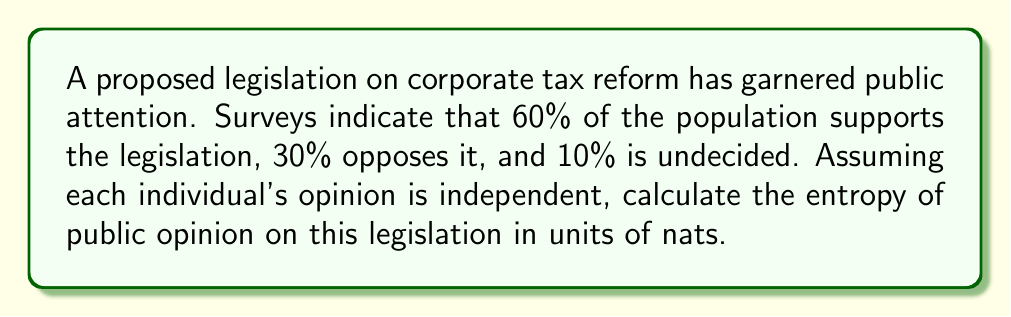Provide a solution to this math problem. To calculate the entropy of public opinion, we'll use the Shannon entropy formula:

$$S = -\sum_{i} p_i \ln(p_i)$$

Where:
$S$ is the entropy
$p_i$ is the probability of each outcome

Step 1: Identify the probabilities
$p_1 = 0.60$ (support)
$p_2 = 0.30$ (oppose)
$p_3 = 0.10$ (undecided)

Step 2: Calculate each term in the sum
Term 1: $-0.60 \ln(0.60) = 0.3067$
Term 2: $-0.30 \ln(0.30) = 0.3612$
Term 3: $-0.10 \ln(0.10) = 0.2303$

Step 3: Sum the terms
$$S = 0.3067 + 0.3612 + 0.2303 = 0.8982$$

The entropy of public opinion on this legislation is approximately 0.8982 nats.

This relatively high entropy indicates significant uncertainty in public opinion, which could be leveraged in lobbying efforts to sway undecided individuals or reinforce existing support.
Answer: 0.8982 nats 